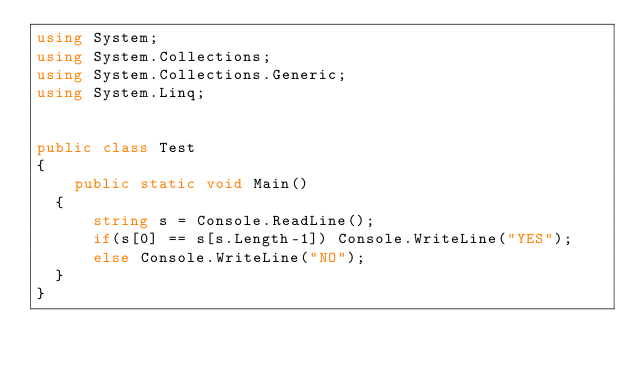<code> <loc_0><loc_0><loc_500><loc_500><_C#_>using System;
using System.Collections;
using System.Collections.Generic;
using System.Linq;


public class Test
{	
    public static void Main()
	{
	    string s = Console.ReadLine();
	    if(s[0] == s[s.Length-1]) Console.WriteLine("YES");
	    else Console.WriteLine("NO");
	} 
}</code> 